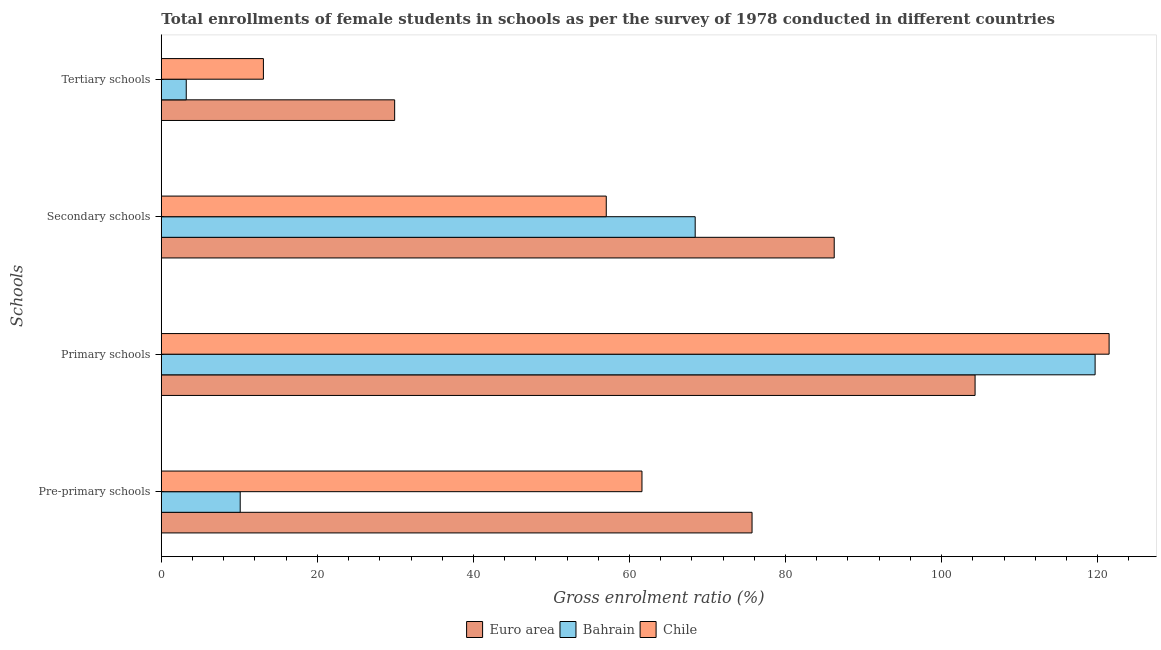How many groups of bars are there?
Provide a short and direct response. 4. Are the number of bars per tick equal to the number of legend labels?
Ensure brevity in your answer.  Yes. How many bars are there on the 3rd tick from the top?
Your response must be concise. 3. What is the label of the 3rd group of bars from the top?
Offer a very short reply. Primary schools. What is the gross enrolment ratio(female) in primary schools in Chile?
Give a very brief answer. 121.47. Across all countries, what is the maximum gross enrolment ratio(female) in tertiary schools?
Your response must be concise. 29.91. Across all countries, what is the minimum gross enrolment ratio(female) in primary schools?
Your response must be concise. 104.29. In which country was the gross enrolment ratio(female) in tertiary schools maximum?
Offer a terse response. Euro area. In which country was the gross enrolment ratio(female) in tertiary schools minimum?
Your answer should be compact. Bahrain. What is the total gross enrolment ratio(female) in tertiary schools in the graph?
Keep it short and to the point. 46.19. What is the difference between the gross enrolment ratio(female) in tertiary schools in Euro area and that in Bahrain?
Offer a terse response. 26.71. What is the difference between the gross enrolment ratio(female) in secondary schools in Bahrain and the gross enrolment ratio(female) in pre-primary schools in Euro area?
Keep it short and to the point. -7.29. What is the average gross enrolment ratio(female) in primary schools per country?
Provide a succinct answer. 115.15. What is the difference between the gross enrolment ratio(female) in primary schools and gross enrolment ratio(female) in secondary schools in Bahrain?
Make the answer very short. 51.25. What is the ratio of the gross enrolment ratio(female) in secondary schools in Chile to that in Euro area?
Make the answer very short. 0.66. Is the difference between the gross enrolment ratio(female) in primary schools in Chile and Bahrain greater than the difference between the gross enrolment ratio(female) in pre-primary schools in Chile and Bahrain?
Your response must be concise. No. What is the difference between the highest and the second highest gross enrolment ratio(female) in tertiary schools?
Provide a succinct answer. 16.82. What is the difference between the highest and the lowest gross enrolment ratio(female) in primary schools?
Your answer should be compact. 17.18. In how many countries, is the gross enrolment ratio(female) in primary schools greater than the average gross enrolment ratio(female) in primary schools taken over all countries?
Your response must be concise. 2. Is it the case that in every country, the sum of the gross enrolment ratio(female) in primary schools and gross enrolment ratio(female) in secondary schools is greater than the sum of gross enrolment ratio(female) in tertiary schools and gross enrolment ratio(female) in pre-primary schools?
Keep it short and to the point. Yes. What does the 2nd bar from the top in Primary schools represents?
Your response must be concise. Bahrain. What does the 2nd bar from the bottom in Pre-primary schools represents?
Your answer should be very brief. Bahrain. Is it the case that in every country, the sum of the gross enrolment ratio(female) in pre-primary schools and gross enrolment ratio(female) in primary schools is greater than the gross enrolment ratio(female) in secondary schools?
Provide a succinct answer. Yes. How many bars are there?
Your answer should be compact. 12. How many countries are there in the graph?
Ensure brevity in your answer.  3. Are the values on the major ticks of X-axis written in scientific E-notation?
Provide a succinct answer. No. Does the graph contain grids?
Make the answer very short. No. How are the legend labels stacked?
Make the answer very short. Horizontal. What is the title of the graph?
Offer a very short reply. Total enrollments of female students in schools as per the survey of 1978 conducted in different countries. Does "Solomon Islands" appear as one of the legend labels in the graph?
Ensure brevity in your answer.  No. What is the label or title of the X-axis?
Offer a terse response. Gross enrolment ratio (%). What is the label or title of the Y-axis?
Provide a succinct answer. Schools. What is the Gross enrolment ratio (%) of Euro area in Pre-primary schools?
Provide a succinct answer. 75.71. What is the Gross enrolment ratio (%) of Bahrain in Pre-primary schools?
Your response must be concise. 10.11. What is the Gross enrolment ratio (%) of Chile in Pre-primary schools?
Your response must be concise. 61.6. What is the Gross enrolment ratio (%) of Euro area in Primary schools?
Your response must be concise. 104.29. What is the Gross enrolment ratio (%) of Bahrain in Primary schools?
Keep it short and to the point. 119.68. What is the Gross enrolment ratio (%) in Chile in Primary schools?
Your answer should be compact. 121.47. What is the Gross enrolment ratio (%) of Euro area in Secondary schools?
Offer a very short reply. 86.24. What is the Gross enrolment ratio (%) of Bahrain in Secondary schools?
Provide a succinct answer. 68.42. What is the Gross enrolment ratio (%) of Chile in Secondary schools?
Your answer should be very brief. 57.03. What is the Gross enrolment ratio (%) of Euro area in Tertiary schools?
Offer a terse response. 29.91. What is the Gross enrolment ratio (%) of Bahrain in Tertiary schools?
Keep it short and to the point. 3.2. What is the Gross enrolment ratio (%) of Chile in Tertiary schools?
Provide a succinct answer. 13.08. Across all Schools, what is the maximum Gross enrolment ratio (%) in Euro area?
Offer a very short reply. 104.29. Across all Schools, what is the maximum Gross enrolment ratio (%) in Bahrain?
Ensure brevity in your answer.  119.68. Across all Schools, what is the maximum Gross enrolment ratio (%) in Chile?
Your answer should be compact. 121.47. Across all Schools, what is the minimum Gross enrolment ratio (%) in Euro area?
Ensure brevity in your answer.  29.91. Across all Schools, what is the minimum Gross enrolment ratio (%) in Bahrain?
Your answer should be compact. 3.2. Across all Schools, what is the minimum Gross enrolment ratio (%) of Chile?
Keep it short and to the point. 13.08. What is the total Gross enrolment ratio (%) in Euro area in the graph?
Provide a short and direct response. 296.15. What is the total Gross enrolment ratio (%) in Bahrain in the graph?
Offer a very short reply. 201.41. What is the total Gross enrolment ratio (%) of Chile in the graph?
Provide a succinct answer. 253.18. What is the difference between the Gross enrolment ratio (%) in Euro area in Pre-primary schools and that in Primary schools?
Your answer should be very brief. -28.58. What is the difference between the Gross enrolment ratio (%) of Bahrain in Pre-primary schools and that in Primary schools?
Make the answer very short. -109.57. What is the difference between the Gross enrolment ratio (%) of Chile in Pre-primary schools and that in Primary schools?
Ensure brevity in your answer.  -59.87. What is the difference between the Gross enrolment ratio (%) of Euro area in Pre-primary schools and that in Secondary schools?
Make the answer very short. -10.53. What is the difference between the Gross enrolment ratio (%) in Bahrain in Pre-primary schools and that in Secondary schools?
Your response must be concise. -58.31. What is the difference between the Gross enrolment ratio (%) in Chile in Pre-primary schools and that in Secondary schools?
Make the answer very short. 4.57. What is the difference between the Gross enrolment ratio (%) of Euro area in Pre-primary schools and that in Tertiary schools?
Provide a short and direct response. 45.8. What is the difference between the Gross enrolment ratio (%) in Bahrain in Pre-primary schools and that in Tertiary schools?
Provide a short and direct response. 6.91. What is the difference between the Gross enrolment ratio (%) of Chile in Pre-primary schools and that in Tertiary schools?
Keep it short and to the point. 48.52. What is the difference between the Gross enrolment ratio (%) of Euro area in Primary schools and that in Secondary schools?
Your answer should be very brief. 18.05. What is the difference between the Gross enrolment ratio (%) in Bahrain in Primary schools and that in Secondary schools?
Ensure brevity in your answer.  51.25. What is the difference between the Gross enrolment ratio (%) in Chile in Primary schools and that in Secondary schools?
Provide a short and direct response. 64.44. What is the difference between the Gross enrolment ratio (%) in Euro area in Primary schools and that in Tertiary schools?
Offer a very short reply. 74.39. What is the difference between the Gross enrolment ratio (%) in Bahrain in Primary schools and that in Tertiary schools?
Give a very brief answer. 116.48. What is the difference between the Gross enrolment ratio (%) in Chile in Primary schools and that in Tertiary schools?
Provide a succinct answer. 108.38. What is the difference between the Gross enrolment ratio (%) in Euro area in Secondary schools and that in Tertiary schools?
Offer a very short reply. 56.33. What is the difference between the Gross enrolment ratio (%) of Bahrain in Secondary schools and that in Tertiary schools?
Ensure brevity in your answer.  65.23. What is the difference between the Gross enrolment ratio (%) of Chile in Secondary schools and that in Tertiary schools?
Provide a short and direct response. 43.94. What is the difference between the Gross enrolment ratio (%) of Euro area in Pre-primary schools and the Gross enrolment ratio (%) of Bahrain in Primary schools?
Offer a terse response. -43.97. What is the difference between the Gross enrolment ratio (%) of Euro area in Pre-primary schools and the Gross enrolment ratio (%) of Chile in Primary schools?
Your answer should be very brief. -45.76. What is the difference between the Gross enrolment ratio (%) in Bahrain in Pre-primary schools and the Gross enrolment ratio (%) in Chile in Primary schools?
Your response must be concise. -111.36. What is the difference between the Gross enrolment ratio (%) in Euro area in Pre-primary schools and the Gross enrolment ratio (%) in Bahrain in Secondary schools?
Give a very brief answer. 7.29. What is the difference between the Gross enrolment ratio (%) of Euro area in Pre-primary schools and the Gross enrolment ratio (%) of Chile in Secondary schools?
Your answer should be compact. 18.68. What is the difference between the Gross enrolment ratio (%) of Bahrain in Pre-primary schools and the Gross enrolment ratio (%) of Chile in Secondary schools?
Your answer should be very brief. -46.92. What is the difference between the Gross enrolment ratio (%) of Euro area in Pre-primary schools and the Gross enrolment ratio (%) of Bahrain in Tertiary schools?
Provide a succinct answer. 72.51. What is the difference between the Gross enrolment ratio (%) of Euro area in Pre-primary schools and the Gross enrolment ratio (%) of Chile in Tertiary schools?
Your answer should be very brief. 62.62. What is the difference between the Gross enrolment ratio (%) of Bahrain in Pre-primary schools and the Gross enrolment ratio (%) of Chile in Tertiary schools?
Provide a short and direct response. -2.97. What is the difference between the Gross enrolment ratio (%) of Euro area in Primary schools and the Gross enrolment ratio (%) of Bahrain in Secondary schools?
Give a very brief answer. 35.87. What is the difference between the Gross enrolment ratio (%) in Euro area in Primary schools and the Gross enrolment ratio (%) in Chile in Secondary schools?
Keep it short and to the point. 47.27. What is the difference between the Gross enrolment ratio (%) in Bahrain in Primary schools and the Gross enrolment ratio (%) in Chile in Secondary schools?
Your answer should be very brief. 62.65. What is the difference between the Gross enrolment ratio (%) in Euro area in Primary schools and the Gross enrolment ratio (%) in Bahrain in Tertiary schools?
Keep it short and to the point. 101.1. What is the difference between the Gross enrolment ratio (%) of Euro area in Primary schools and the Gross enrolment ratio (%) of Chile in Tertiary schools?
Ensure brevity in your answer.  91.21. What is the difference between the Gross enrolment ratio (%) of Bahrain in Primary schools and the Gross enrolment ratio (%) of Chile in Tertiary schools?
Offer a very short reply. 106.59. What is the difference between the Gross enrolment ratio (%) of Euro area in Secondary schools and the Gross enrolment ratio (%) of Bahrain in Tertiary schools?
Provide a succinct answer. 83.04. What is the difference between the Gross enrolment ratio (%) in Euro area in Secondary schools and the Gross enrolment ratio (%) in Chile in Tertiary schools?
Your response must be concise. 73.16. What is the difference between the Gross enrolment ratio (%) of Bahrain in Secondary schools and the Gross enrolment ratio (%) of Chile in Tertiary schools?
Give a very brief answer. 55.34. What is the average Gross enrolment ratio (%) in Euro area per Schools?
Your response must be concise. 74.04. What is the average Gross enrolment ratio (%) in Bahrain per Schools?
Your response must be concise. 50.35. What is the average Gross enrolment ratio (%) of Chile per Schools?
Your response must be concise. 63.3. What is the difference between the Gross enrolment ratio (%) in Euro area and Gross enrolment ratio (%) in Bahrain in Pre-primary schools?
Provide a short and direct response. 65.6. What is the difference between the Gross enrolment ratio (%) of Euro area and Gross enrolment ratio (%) of Chile in Pre-primary schools?
Give a very brief answer. 14.11. What is the difference between the Gross enrolment ratio (%) in Bahrain and Gross enrolment ratio (%) in Chile in Pre-primary schools?
Your answer should be compact. -51.49. What is the difference between the Gross enrolment ratio (%) in Euro area and Gross enrolment ratio (%) in Bahrain in Primary schools?
Your answer should be very brief. -15.38. What is the difference between the Gross enrolment ratio (%) of Euro area and Gross enrolment ratio (%) of Chile in Primary schools?
Ensure brevity in your answer.  -17.18. What is the difference between the Gross enrolment ratio (%) of Bahrain and Gross enrolment ratio (%) of Chile in Primary schools?
Your response must be concise. -1.79. What is the difference between the Gross enrolment ratio (%) in Euro area and Gross enrolment ratio (%) in Bahrain in Secondary schools?
Make the answer very short. 17.82. What is the difference between the Gross enrolment ratio (%) of Euro area and Gross enrolment ratio (%) of Chile in Secondary schools?
Your answer should be very brief. 29.21. What is the difference between the Gross enrolment ratio (%) of Bahrain and Gross enrolment ratio (%) of Chile in Secondary schools?
Give a very brief answer. 11.4. What is the difference between the Gross enrolment ratio (%) of Euro area and Gross enrolment ratio (%) of Bahrain in Tertiary schools?
Provide a succinct answer. 26.71. What is the difference between the Gross enrolment ratio (%) in Euro area and Gross enrolment ratio (%) in Chile in Tertiary schools?
Give a very brief answer. 16.82. What is the difference between the Gross enrolment ratio (%) in Bahrain and Gross enrolment ratio (%) in Chile in Tertiary schools?
Provide a short and direct response. -9.89. What is the ratio of the Gross enrolment ratio (%) in Euro area in Pre-primary schools to that in Primary schools?
Your answer should be very brief. 0.73. What is the ratio of the Gross enrolment ratio (%) in Bahrain in Pre-primary schools to that in Primary schools?
Your answer should be very brief. 0.08. What is the ratio of the Gross enrolment ratio (%) in Chile in Pre-primary schools to that in Primary schools?
Ensure brevity in your answer.  0.51. What is the ratio of the Gross enrolment ratio (%) of Euro area in Pre-primary schools to that in Secondary schools?
Give a very brief answer. 0.88. What is the ratio of the Gross enrolment ratio (%) in Bahrain in Pre-primary schools to that in Secondary schools?
Offer a terse response. 0.15. What is the ratio of the Gross enrolment ratio (%) in Chile in Pre-primary schools to that in Secondary schools?
Provide a short and direct response. 1.08. What is the ratio of the Gross enrolment ratio (%) of Euro area in Pre-primary schools to that in Tertiary schools?
Provide a succinct answer. 2.53. What is the ratio of the Gross enrolment ratio (%) of Bahrain in Pre-primary schools to that in Tertiary schools?
Make the answer very short. 3.16. What is the ratio of the Gross enrolment ratio (%) of Chile in Pre-primary schools to that in Tertiary schools?
Provide a short and direct response. 4.71. What is the ratio of the Gross enrolment ratio (%) of Euro area in Primary schools to that in Secondary schools?
Provide a short and direct response. 1.21. What is the ratio of the Gross enrolment ratio (%) of Bahrain in Primary schools to that in Secondary schools?
Provide a short and direct response. 1.75. What is the ratio of the Gross enrolment ratio (%) in Chile in Primary schools to that in Secondary schools?
Your answer should be very brief. 2.13. What is the ratio of the Gross enrolment ratio (%) in Euro area in Primary schools to that in Tertiary schools?
Your answer should be very brief. 3.49. What is the ratio of the Gross enrolment ratio (%) in Bahrain in Primary schools to that in Tertiary schools?
Provide a succinct answer. 37.44. What is the ratio of the Gross enrolment ratio (%) of Chile in Primary schools to that in Tertiary schools?
Provide a short and direct response. 9.28. What is the ratio of the Gross enrolment ratio (%) of Euro area in Secondary schools to that in Tertiary schools?
Offer a terse response. 2.88. What is the ratio of the Gross enrolment ratio (%) in Bahrain in Secondary schools to that in Tertiary schools?
Provide a short and direct response. 21.41. What is the ratio of the Gross enrolment ratio (%) of Chile in Secondary schools to that in Tertiary schools?
Give a very brief answer. 4.36. What is the difference between the highest and the second highest Gross enrolment ratio (%) of Euro area?
Your response must be concise. 18.05. What is the difference between the highest and the second highest Gross enrolment ratio (%) in Bahrain?
Provide a short and direct response. 51.25. What is the difference between the highest and the second highest Gross enrolment ratio (%) of Chile?
Make the answer very short. 59.87. What is the difference between the highest and the lowest Gross enrolment ratio (%) of Euro area?
Offer a very short reply. 74.39. What is the difference between the highest and the lowest Gross enrolment ratio (%) of Bahrain?
Make the answer very short. 116.48. What is the difference between the highest and the lowest Gross enrolment ratio (%) in Chile?
Your answer should be compact. 108.38. 